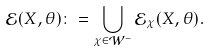Convert formula to latex. <formula><loc_0><loc_0><loc_500><loc_500>\mathcal { E } ( X , \theta ) \colon = \bigcup _ { \chi \in \mathcal { W } ^ { - } } \mathcal { E } _ { \chi } ( X , \theta ) .</formula> 